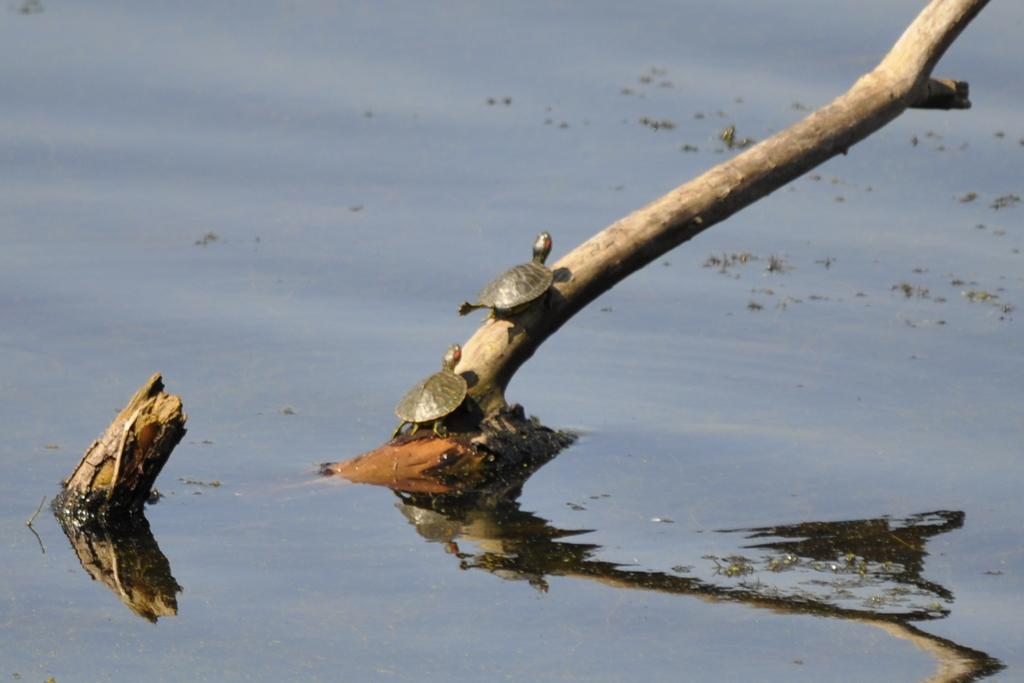What animals are present in the image? There are tortoises in the image. How are the tortoises positioned in the image? The tortoises are on a stick. What can be seen at the bottom of the image? There is water visible at the bottom of the image. What type of scissors can be seen in the image? There are no scissors present in the image. 